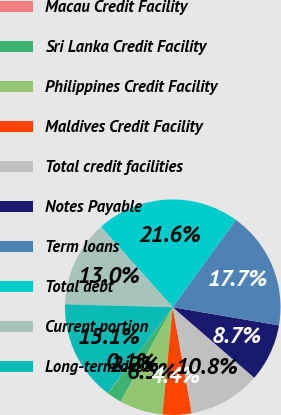Convert chart to OTSL. <chart><loc_0><loc_0><loc_500><loc_500><pie_chart><fcel>Macau Credit Facility<fcel>Sri Lanka Credit Facility<fcel>Philippines Credit Facility<fcel>Maldives Credit Facility<fcel>Total credit facilities<fcel>Notes Payable<fcel>Term loans<fcel>Total debt<fcel>Current portion<fcel>Long-term debt<nl><fcel>0.06%<fcel>2.21%<fcel>6.51%<fcel>4.36%<fcel>10.81%<fcel>8.66%<fcel>17.72%<fcel>21.57%<fcel>12.97%<fcel>15.12%<nl></chart> 